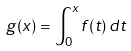<formula> <loc_0><loc_0><loc_500><loc_500>g ( x ) = \int _ { 0 } ^ { x } f ( t ) \, d t</formula> 